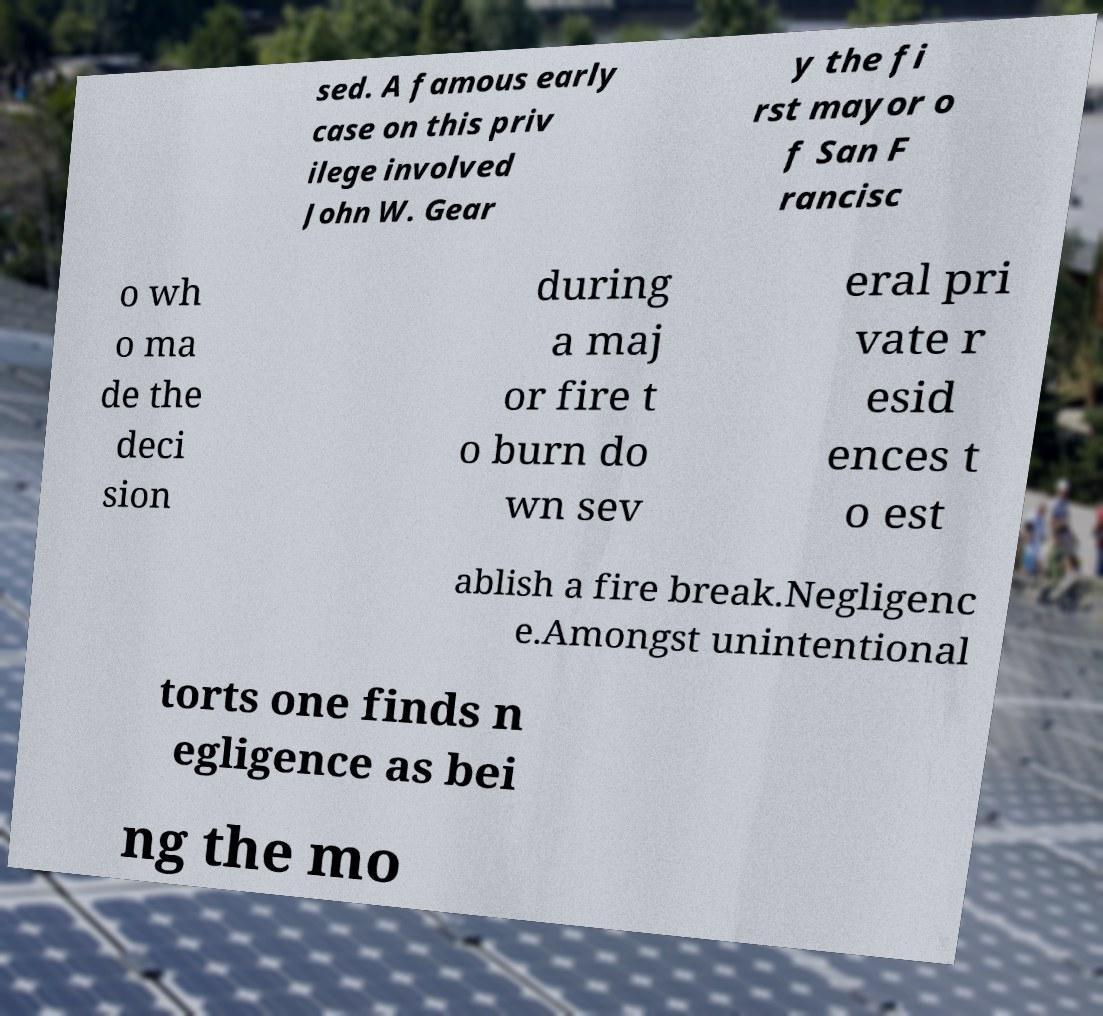What messages or text are displayed in this image? I need them in a readable, typed format. sed. A famous early case on this priv ilege involved John W. Gear y the fi rst mayor o f San F rancisc o wh o ma de the deci sion during a maj or fire t o burn do wn sev eral pri vate r esid ences t o est ablish a fire break.Negligenc e.Amongst unintentional torts one finds n egligence as bei ng the mo 